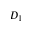<formula> <loc_0><loc_0><loc_500><loc_500>D _ { 1 }</formula> 